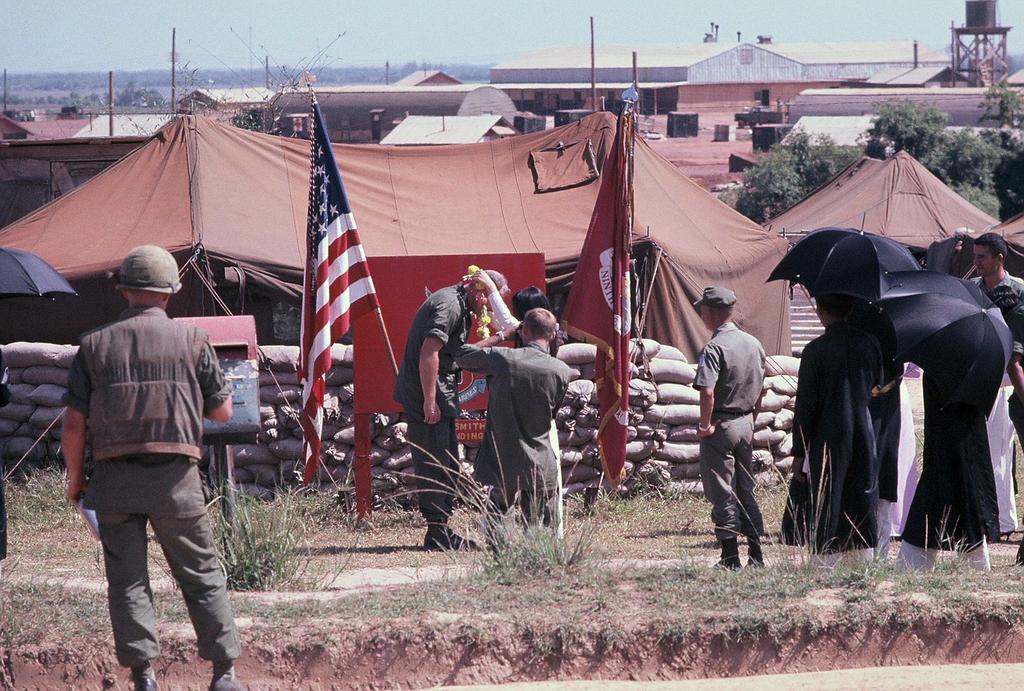Describe this image in one or two sentences. In the image we can see there are people standing, wearing clothes and some of them are wearing shoes and hats. Here we can see the flag of the country, where we can see grass, tent, poles and building. Here we can see some people holding umbrellas. Here we can see trees and the sky. 